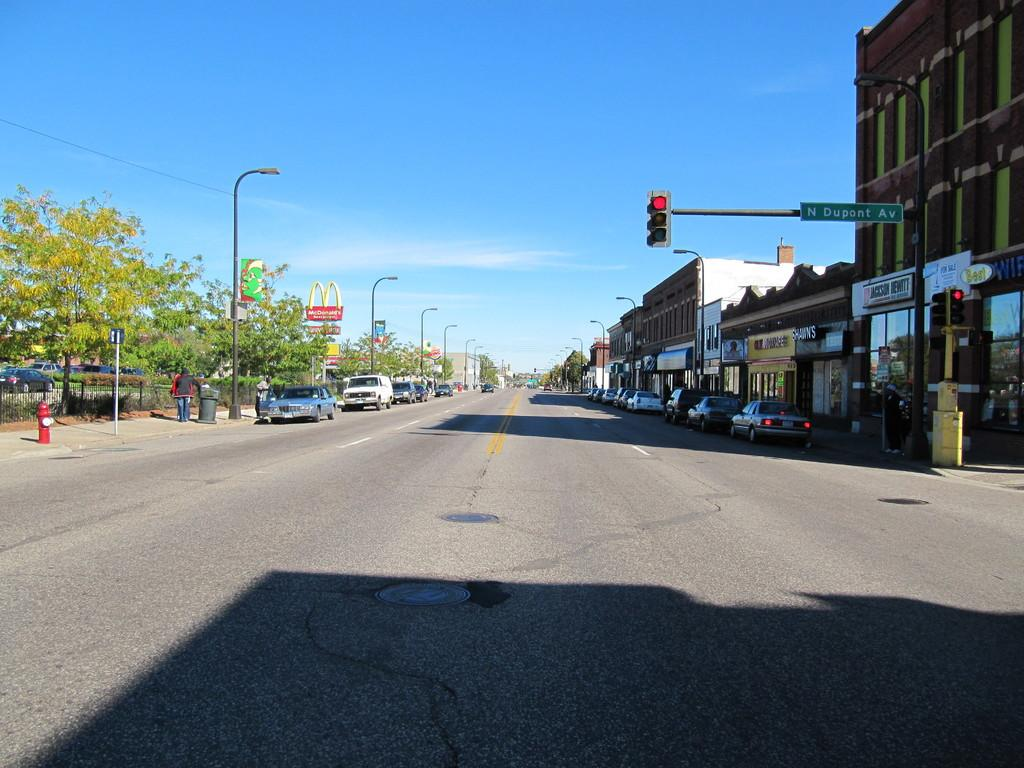<image>
Render a clear and concise summary of the photo. the word dupont that is above the street 